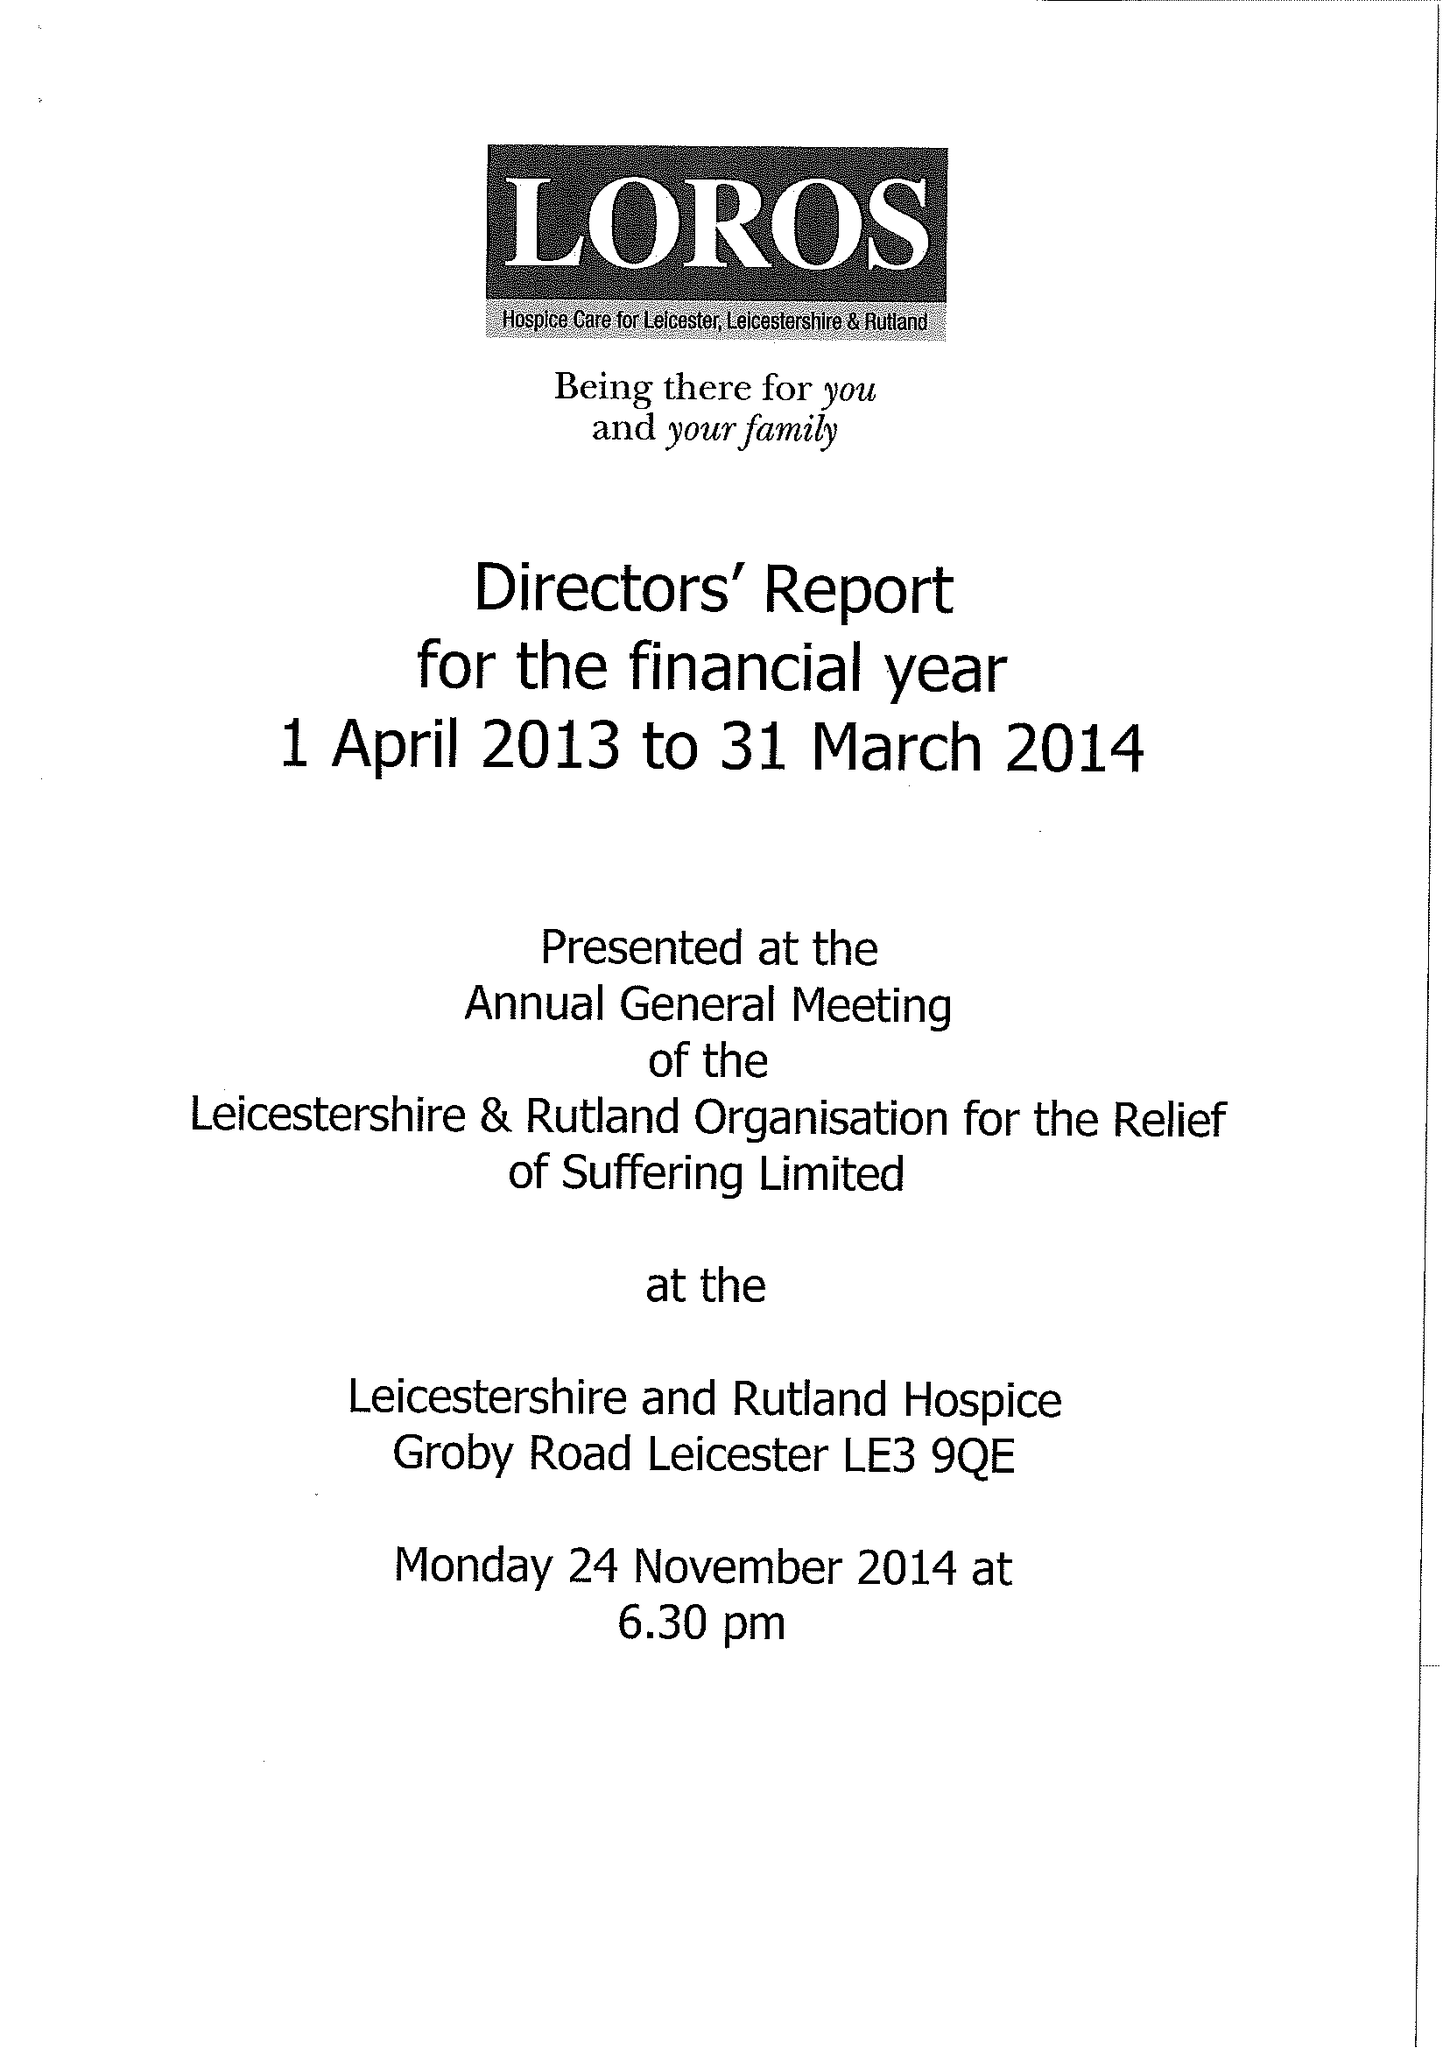What is the value for the charity_name?
Answer the question using a single word or phrase. Leicestershire and Rutland Organisation For The Relief Of Suffering Ltd. 